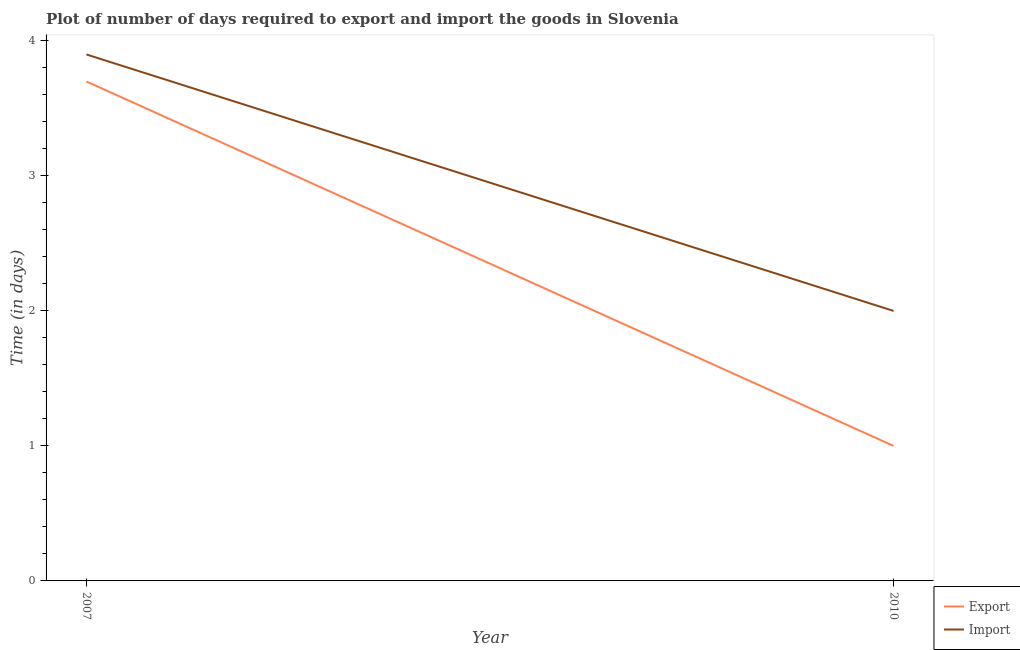How many different coloured lines are there?
Provide a short and direct response. 2. Does the line corresponding to time required to export intersect with the line corresponding to time required to import?
Ensure brevity in your answer.  No. Across all years, what is the maximum time required to import?
Offer a very short reply. 3.9. Across all years, what is the minimum time required to export?
Keep it short and to the point. 1. In which year was the time required to export minimum?
Your answer should be compact. 2010. What is the total time required to import in the graph?
Ensure brevity in your answer.  5.9. What is the difference between the time required to import in 2007 and that in 2010?
Keep it short and to the point. 1.9. What is the difference between the time required to import in 2010 and the time required to export in 2007?
Ensure brevity in your answer.  -1.7. What is the average time required to export per year?
Offer a terse response. 2.35. In the year 2007, what is the difference between the time required to import and time required to export?
Provide a short and direct response. 0.2. What is the ratio of the time required to export in 2007 to that in 2010?
Your answer should be compact. 3.7. What is the difference between two consecutive major ticks on the Y-axis?
Make the answer very short. 1. How many legend labels are there?
Provide a short and direct response. 2. What is the title of the graph?
Your answer should be very brief. Plot of number of days required to export and import the goods in Slovenia. Does "Goods" appear as one of the legend labels in the graph?
Ensure brevity in your answer.  No. What is the label or title of the Y-axis?
Keep it short and to the point. Time (in days). What is the Time (in days) of Export in 2007?
Provide a short and direct response. 3.7. What is the Time (in days) of Import in 2007?
Provide a succinct answer. 3.9. Across all years, what is the maximum Time (in days) in Export?
Your response must be concise. 3.7. What is the total Time (in days) in Import in the graph?
Give a very brief answer. 5.9. What is the difference between the Time (in days) in Export in 2007 and that in 2010?
Give a very brief answer. 2.7. What is the difference between the Time (in days) of Import in 2007 and that in 2010?
Offer a terse response. 1.9. What is the difference between the Time (in days) of Export in 2007 and the Time (in days) of Import in 2010?
Provide a short and direct response. 1.7. What is the average Time (in days) in Export per year?
Your answer should be very brief. 2.35. What is the average Time (in days) of Import per year?
Provide a short and direct response. 2.95. In the year 2010, what is the difference between the Time (in days) of Export and Time (in days) of Import?
Offer a very short reply. -1. What is the ratio of the Time (in days) of Import in 2007 to that in 2010?
Make the answer very short. 1.95. What is the difference between the highest and the lowest Time (in days) of Export?
Your answer should be very brief. 2.7. What is the difference between the highest and the lowest Time (in days) of Import?
Keep it short and to the point. 1.9. 